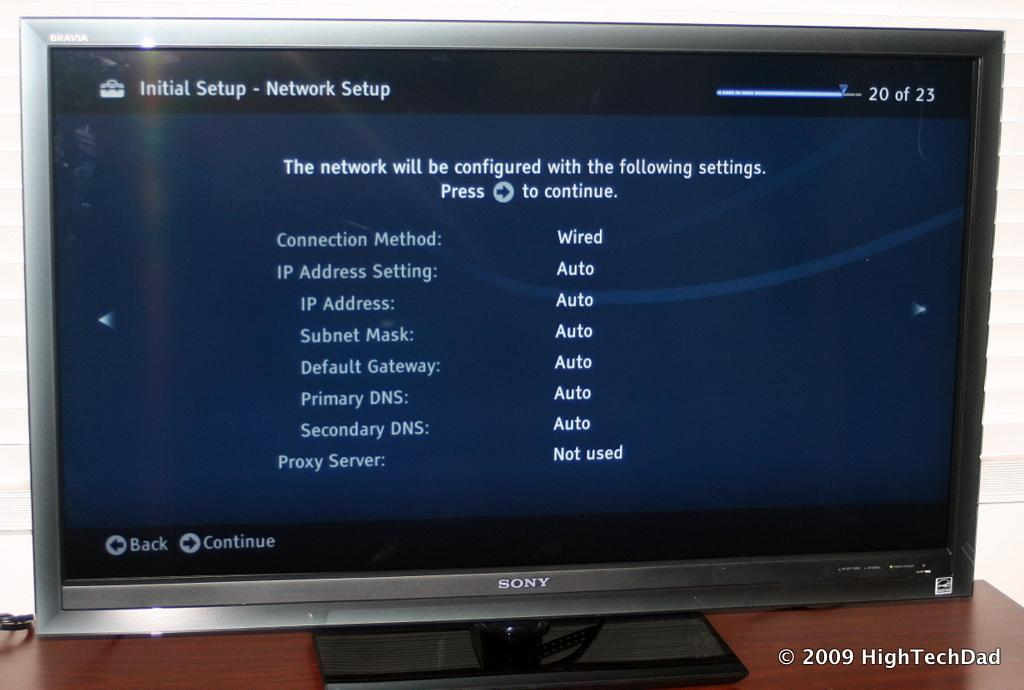<image>
Write a terse but informative summary of the picture. a phrase about the network on a black and white screen 